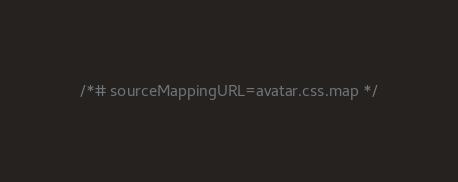<code> <loc_0><loc_0><loc_500><loc_500><_CSS_>

/*# sourceMappingURL=avatar.css.map */
</code> 